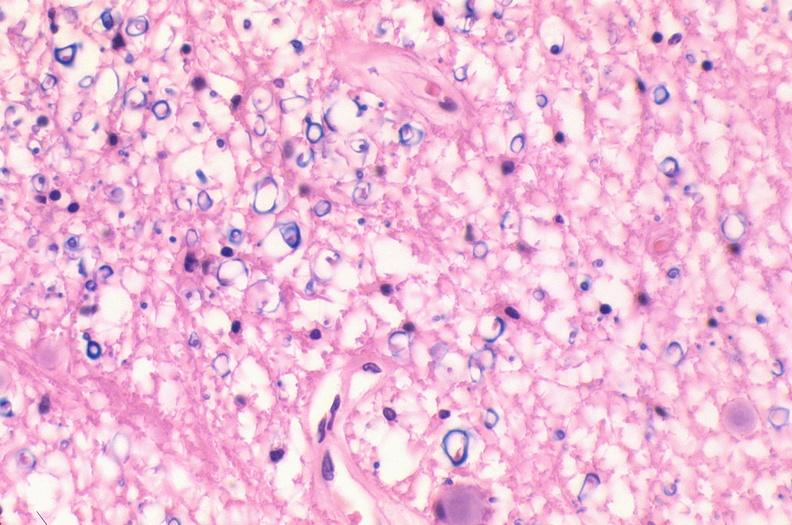s nervous present?
Answer the question using a single word or phrase. Yes 